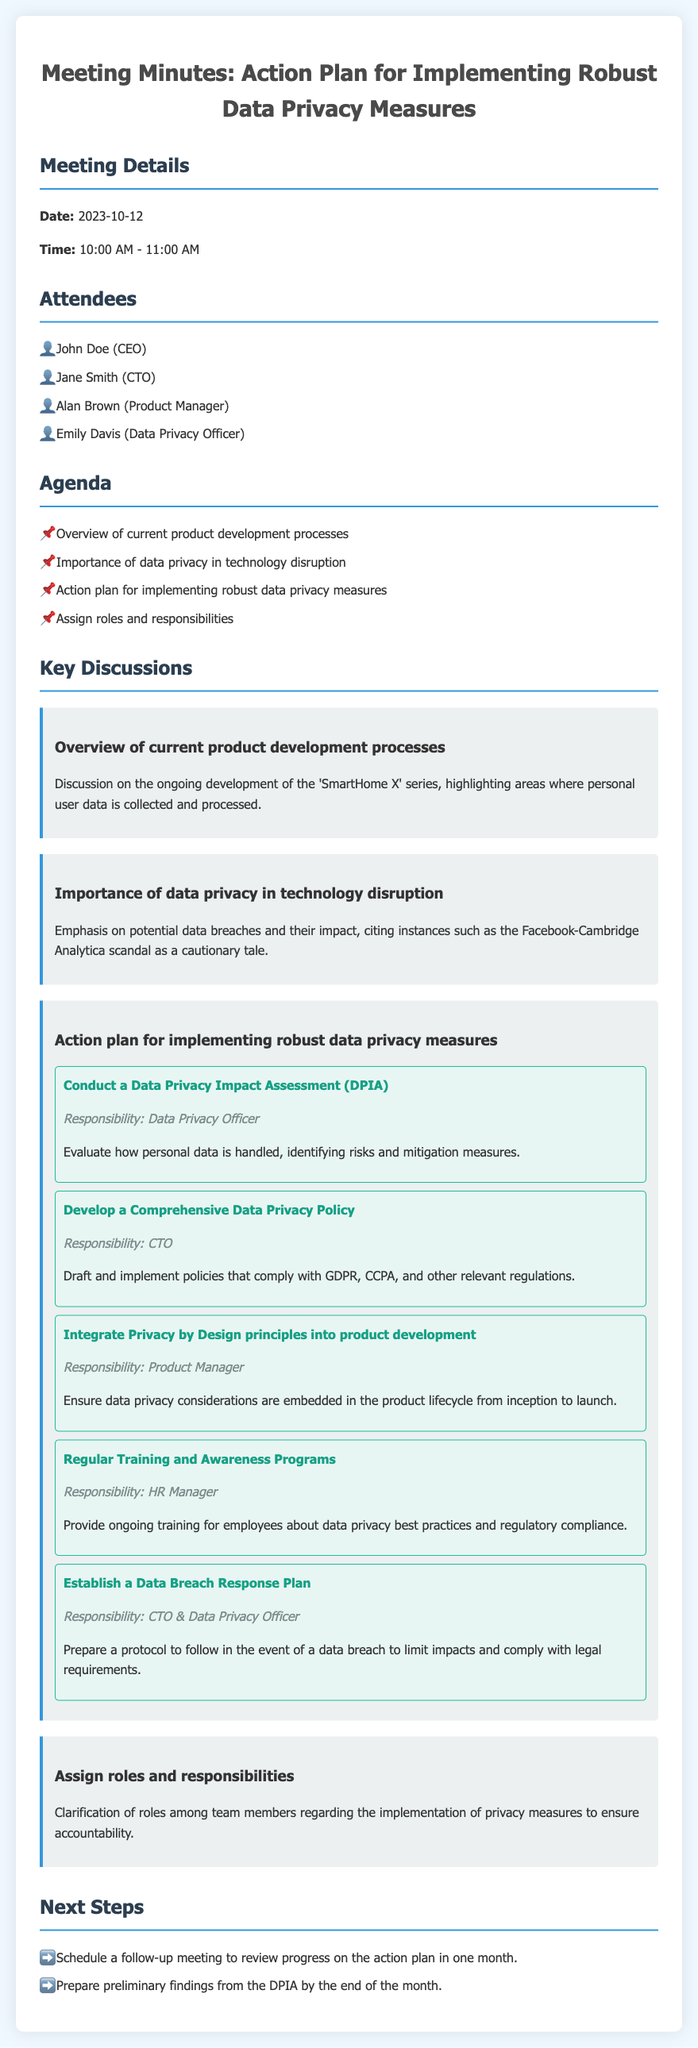What is the date of the meeting? The meeting date is explicitly stated in the document.
Answer: 2023-10-12 Who is responsible for conducting the Data Privacy Impact Assessment? The responsibility for the DPIA is assigned to a specific role mentioned in the action plan section.
Answer: Data Privacy Officer What key product is mentioned in the current product development processes? The document specifically highlights the ongoing development project discussed.
Answer: SmartHome X What is the next step scheduled to review the action plan progress? The document lists the next steps that include scheduling follow-up actions.
Answer: Follow-up meeting Which regulation should the Comprehensive Data Privacy Policy comply with? The document lists specific regulations that the policy must address.
Answer: GDPR, CCPA What is emphasized as important in the discussion on data privacy? The document outlines critical points discussed regarding data privacy's impact.
Answer: Data breaches Who will develop the Comprehensive Data Privacy Policy? The document assigns responsibility for drafting the privacy policy to a specific role.
Answer: CTO Which team member is responsible for Regular Training and Awareness Programs? The action steps assign specific responsibilities to team members for various tasks.
Answer: HR Manager 